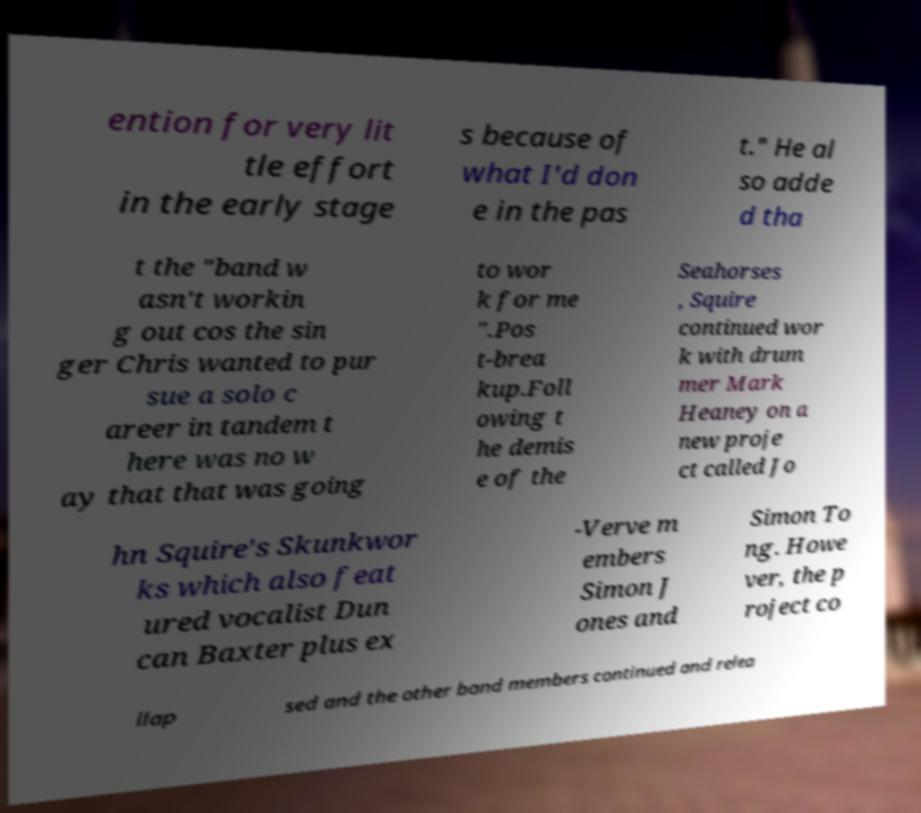Could you extract and type out the text from this image? ention for very lit tle effort in the early stage s because of what I'd don e in the pas t." He al so adde d tha t the "band w asn't workin g out cos the sin ger Chris wanted to pur sue a solo c areer in tandem t here was no w ay that that was going to wor k for me ".Pos t-brea kup.Foll owing t he demis e of the Seahorses , Squire continued wor k with drum mer Mark Heaney on a new proje ct called Jo hn Squire's Skunkwor ks which also feat ured vocalist Dun can Baxter plus ex -Verve m embers Simon J ones and Simon To ng. Howe ver, the p roject co llap sed and the other band members continued and relea 